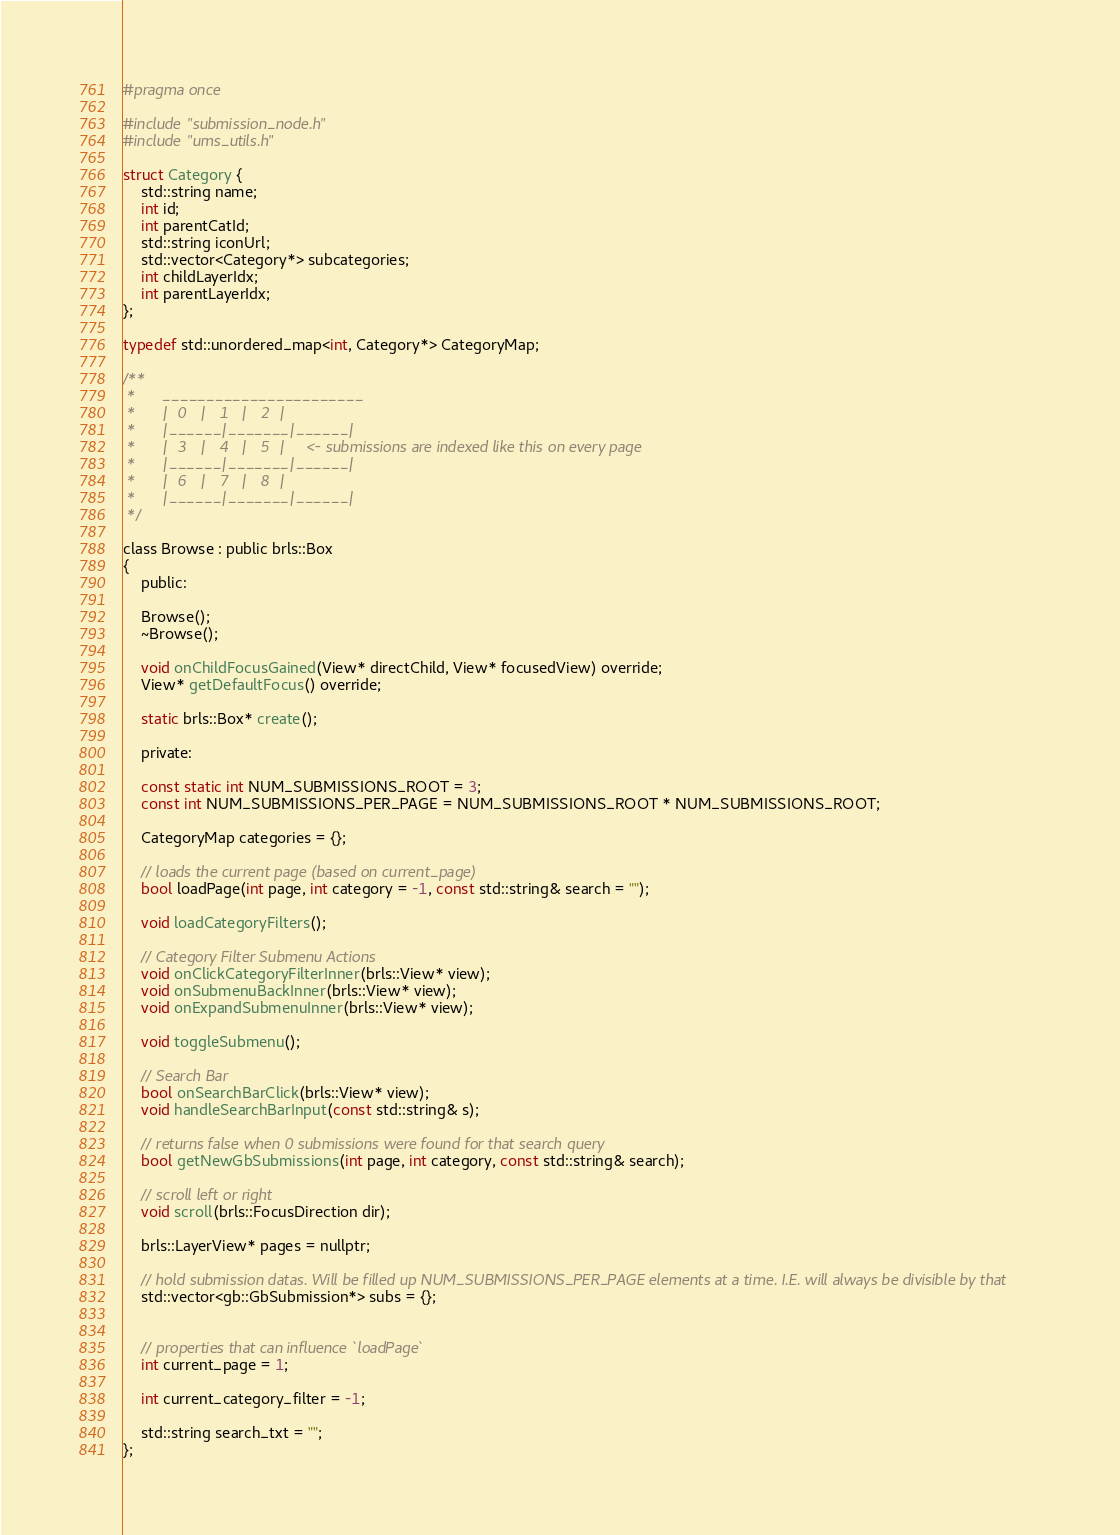Convert code to text. <code><loc_0><loc_0><loc_500><loc_500><_C_>#pragma once

#include "submission_node.h"
#include "ums_utils.h"

struct Category {
    std::string name;
    int id;
    int parentCatId;
    std::string iconUrl;
    std::vector<Category*> subcategories;
    int childLayerIdx;
    int parentLayerIdx;
};

typedef std::unordered_map<int, Category*> CategoryMap;

/** 
 *      _______________________
 *      |  0   |   1   |   2  |
 *      |______|_______|______|
 *      |  3   |   4   |   5  |     <- submissions are indexed like this on every page
 *      |______|_______|______|
 *      |  6   |   7   |   8  |
 *      |______|_______|______|
 */

class Browse : public brls::Box
{
    public:

    Browse();
    ~Browse();

    void onChildFocusGained(View* directChild, View* focusedView) override;
    View* getDefaultFocus() override;

    static brls::Box* create();

    private:

    const static int NUM_SUBMISSIONS_ROOT = 3;
    const int NUM_SUBMISSIONS_PER_PAGE = NUM_SUBMISSIONS_ROOT * NUM_SUBMISSIONS_ROOT;

    CategoryMap categories = {};

    // loads the current page (based on current_page)
    bool loadPage(int page, int category = -1, const std::string& search = "");

    void loadCategoryFilters();

    // Category Filter Submenu Actions
    void onClickCategoryFilterInner(brls::View* view);
    void onSubmenuBackInner(brls::View* view);
    void onExpandSubmenuInner(brls::View* view);

    void toggleSubmenu();

    // Search Bar
    bool onSearchBarClick(brls::View* view);
    void handleSearchBarInput(const std::string& s);

    // returns false when 0 submissions were found for that search query
    bool getNewGbSubmissions(int page, int category, const std::string& search);

    // scroll left or right
    void scroll(brls::FocusDirection dir);

    brls::LayerView* pages = nullptr;

    // hold submission datas. Will be filled up NUM_SUBMISSIONS_PER_PAGE elements at a time. I.E. will always be divisible by that
    std::vector<gb::GbSubmission*> subs = {};


    // properties that can influence `loadPage`
    int current_page = 1;

    int current_category_filter = -1;

    std::string search_txt = "";
};</code> 